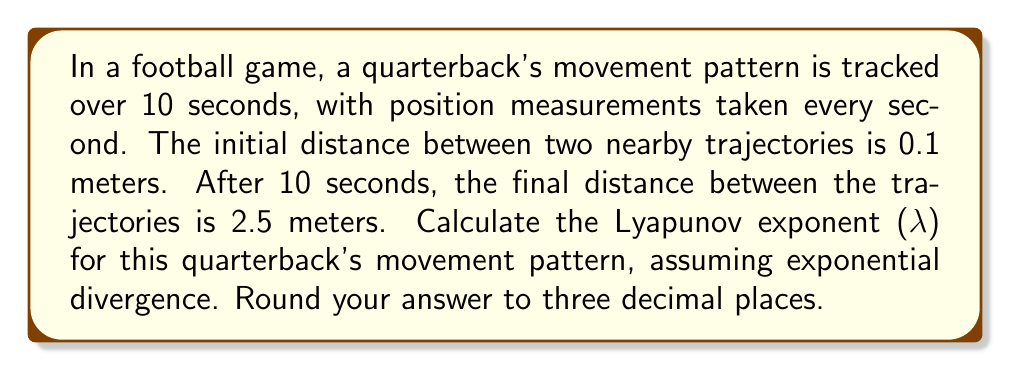Solve this math problem. To determine the Lyapunov exponent (λ) for the quarterback's movement pattern, we'll follow these steps:

1. Recall the formula for the Lyapunov exponent:

   $$λ = \frac{1}{t} \ln\left(\frac{d(t)}{d(0)}\right)$$

   where:
   - $t$ is the time elapsed
   - $d(0)$ is the initial distance between trajectories
   - $d(t)$ is the final distance between trajectories

2. Substitute the given values:
   - $t = 10$ seconds
   - $d(0) = 0.1$ meters
   - $d(t) = d(10) = 2.5$ meters

3. Apply the formula:

   $$λ = \frac{1}{10} \ln\left(\frac{2.5}{0.1}\right)$$

4. Simplify the fraction inside the logarithm:

   $$λ = \frac{1}{10} \ln(25)$$

5. Calculate the natural logarithm:

   $$λ = \frac{1}{10} \cdot 3.2188758248682006...$$

6. Divide by 10:

   $$λ = 0.32188758248682006...$$

7. Round to three decimal places:

   $$λ ≈ 0.322$$

This positive Lyapunov exponent indicates that the quarterback's movement pattern exhibits chaotic behavior, with nearby trajectories diverging exponentially over time.
Answer: $0.322$ 